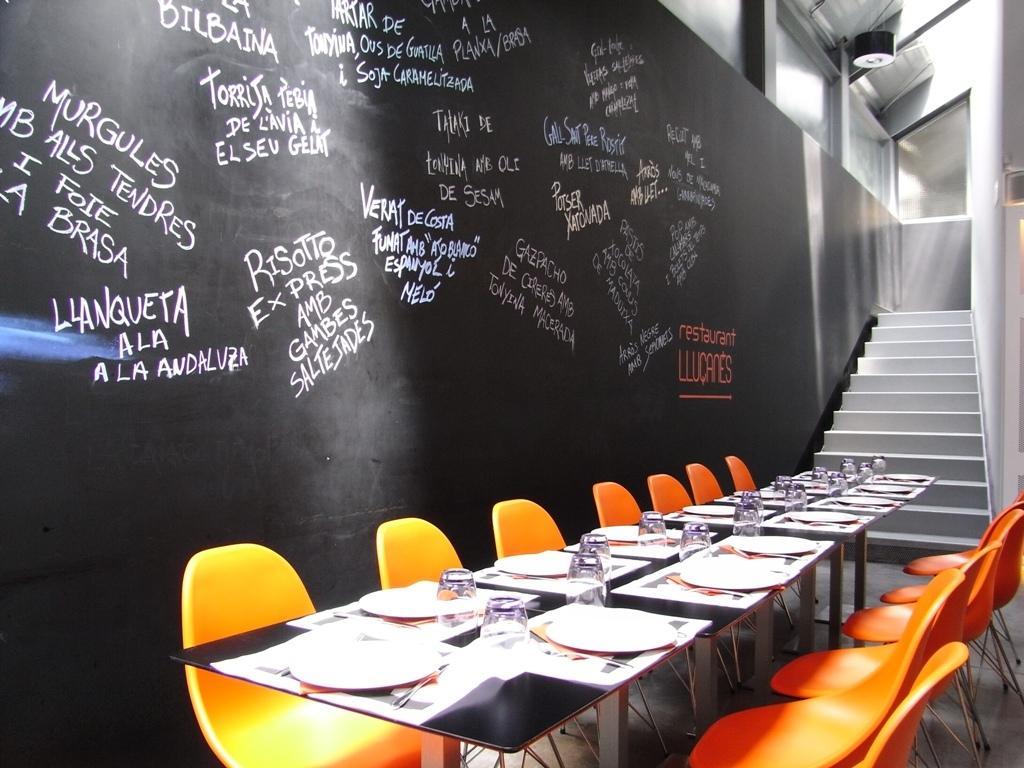Can you describe this image briefly? On this table there are plates and glasses. Beside this table there are orange chairs. Here we can see steps. Something written on this black wall. 